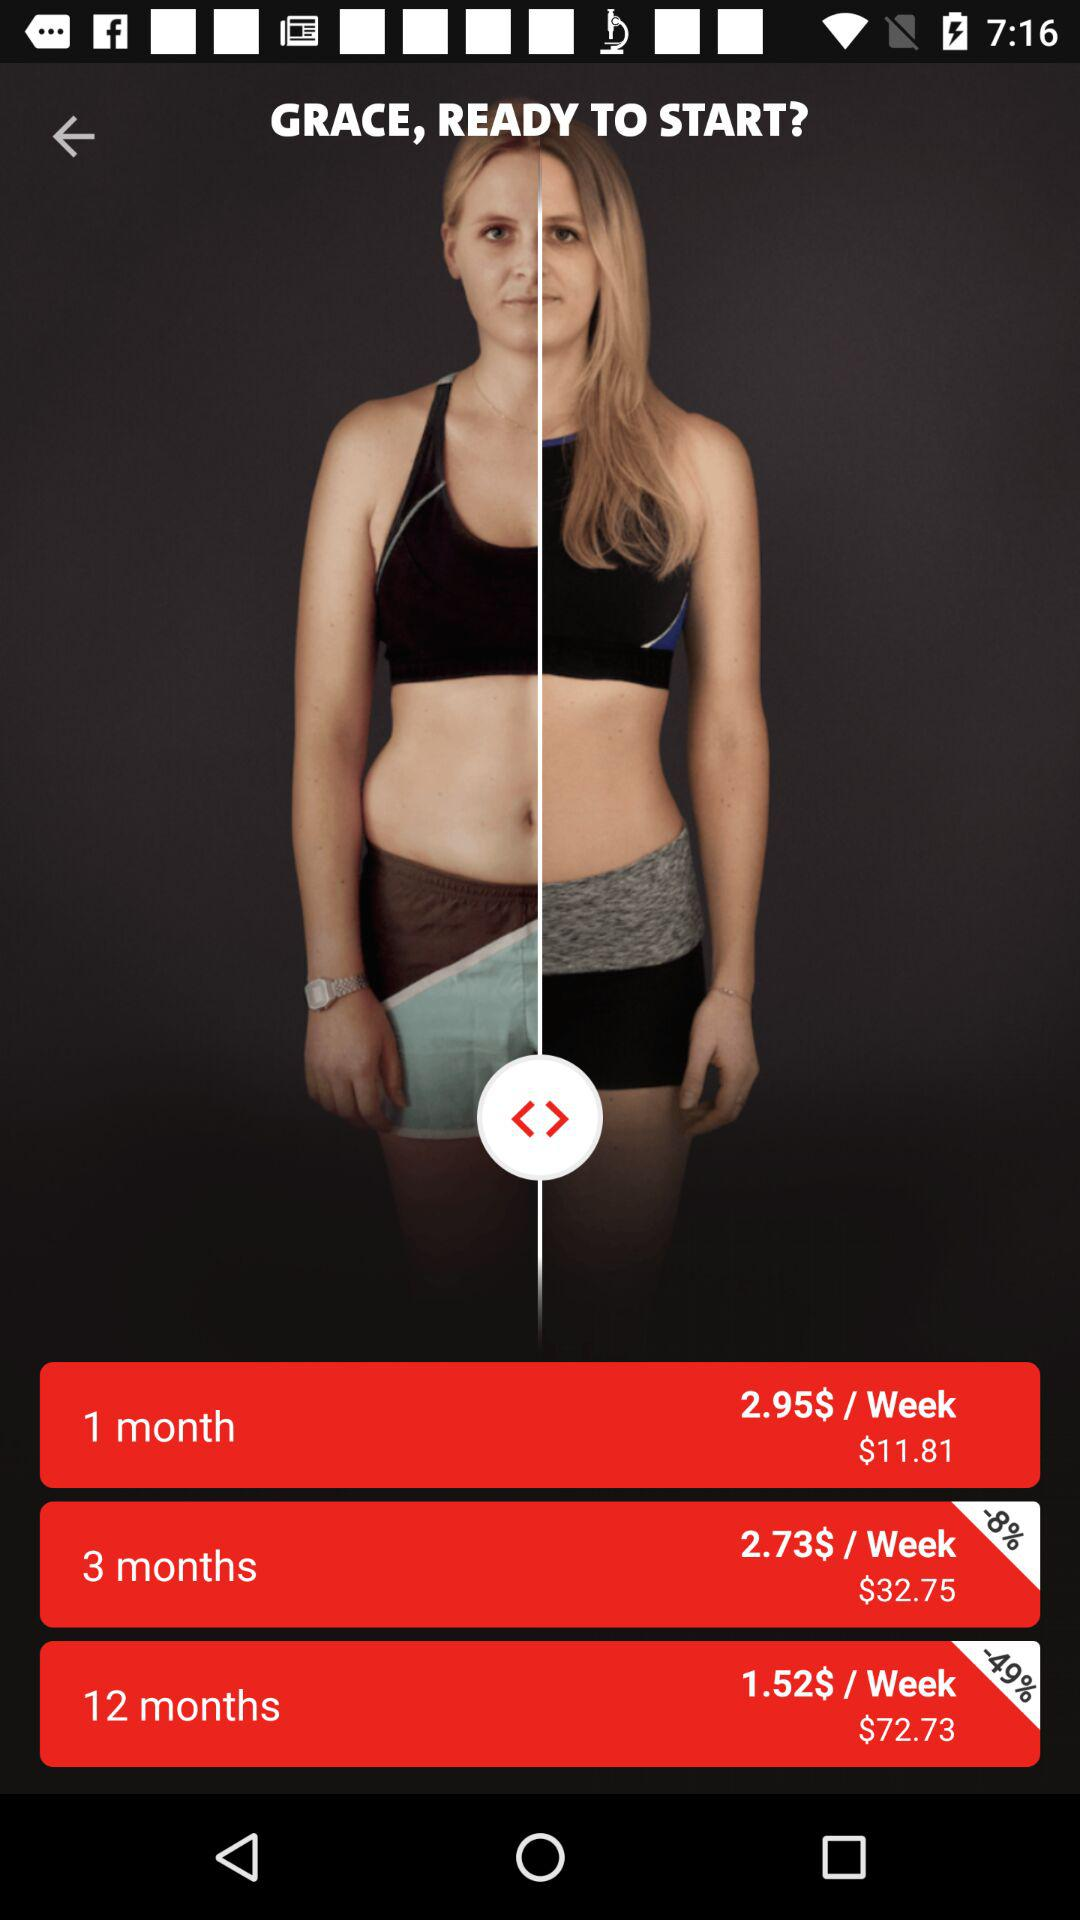How much of a discount is available on the plan for 12 months? The discount available on the plan for 12 months is 49%. 